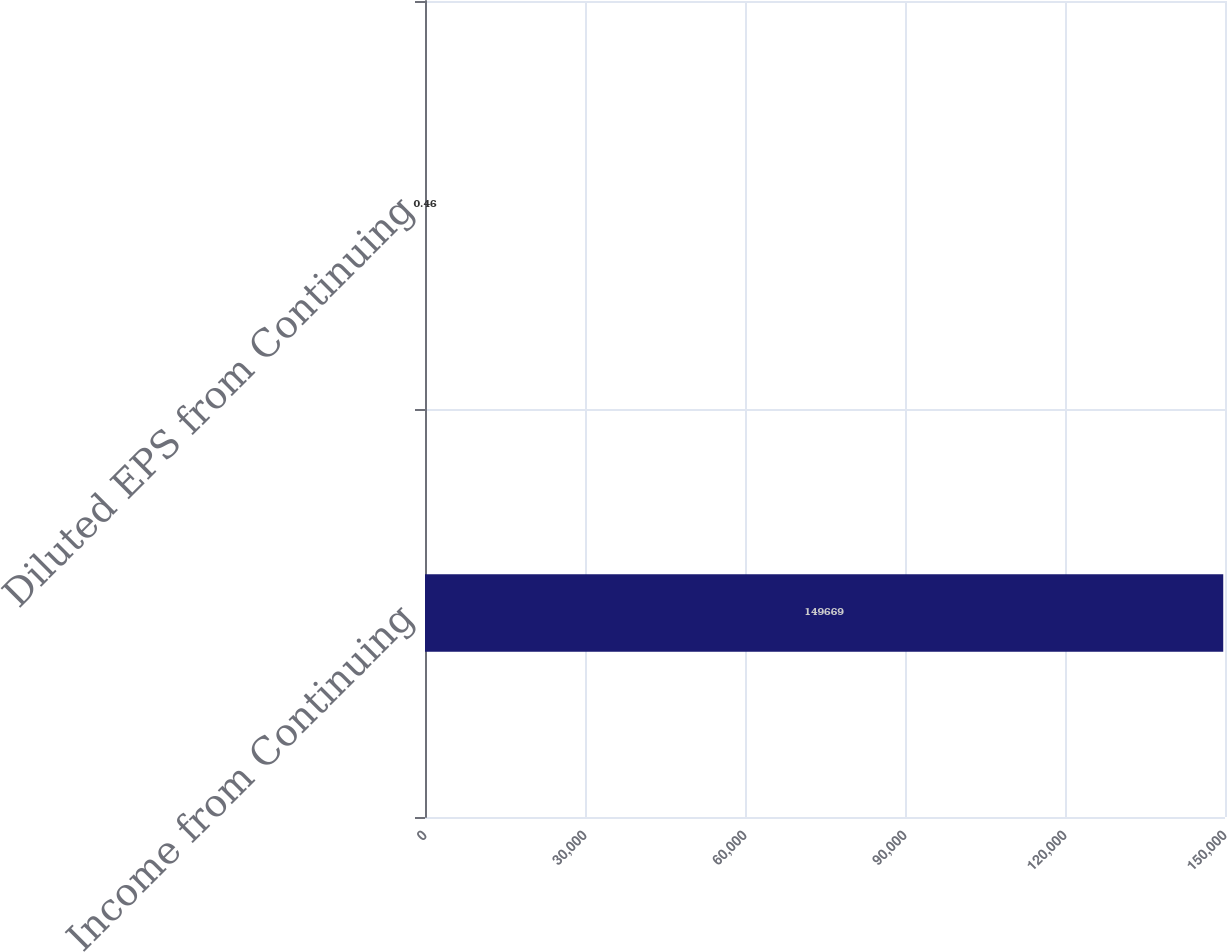<chart> <loc_0><loc_0><loc_500><loc_500><bar_chart><fcel>Income from Continuing<fcel>Diluted EPS from Continuing<nl><fcel>149669<fcel>0.46<nl></chart> 